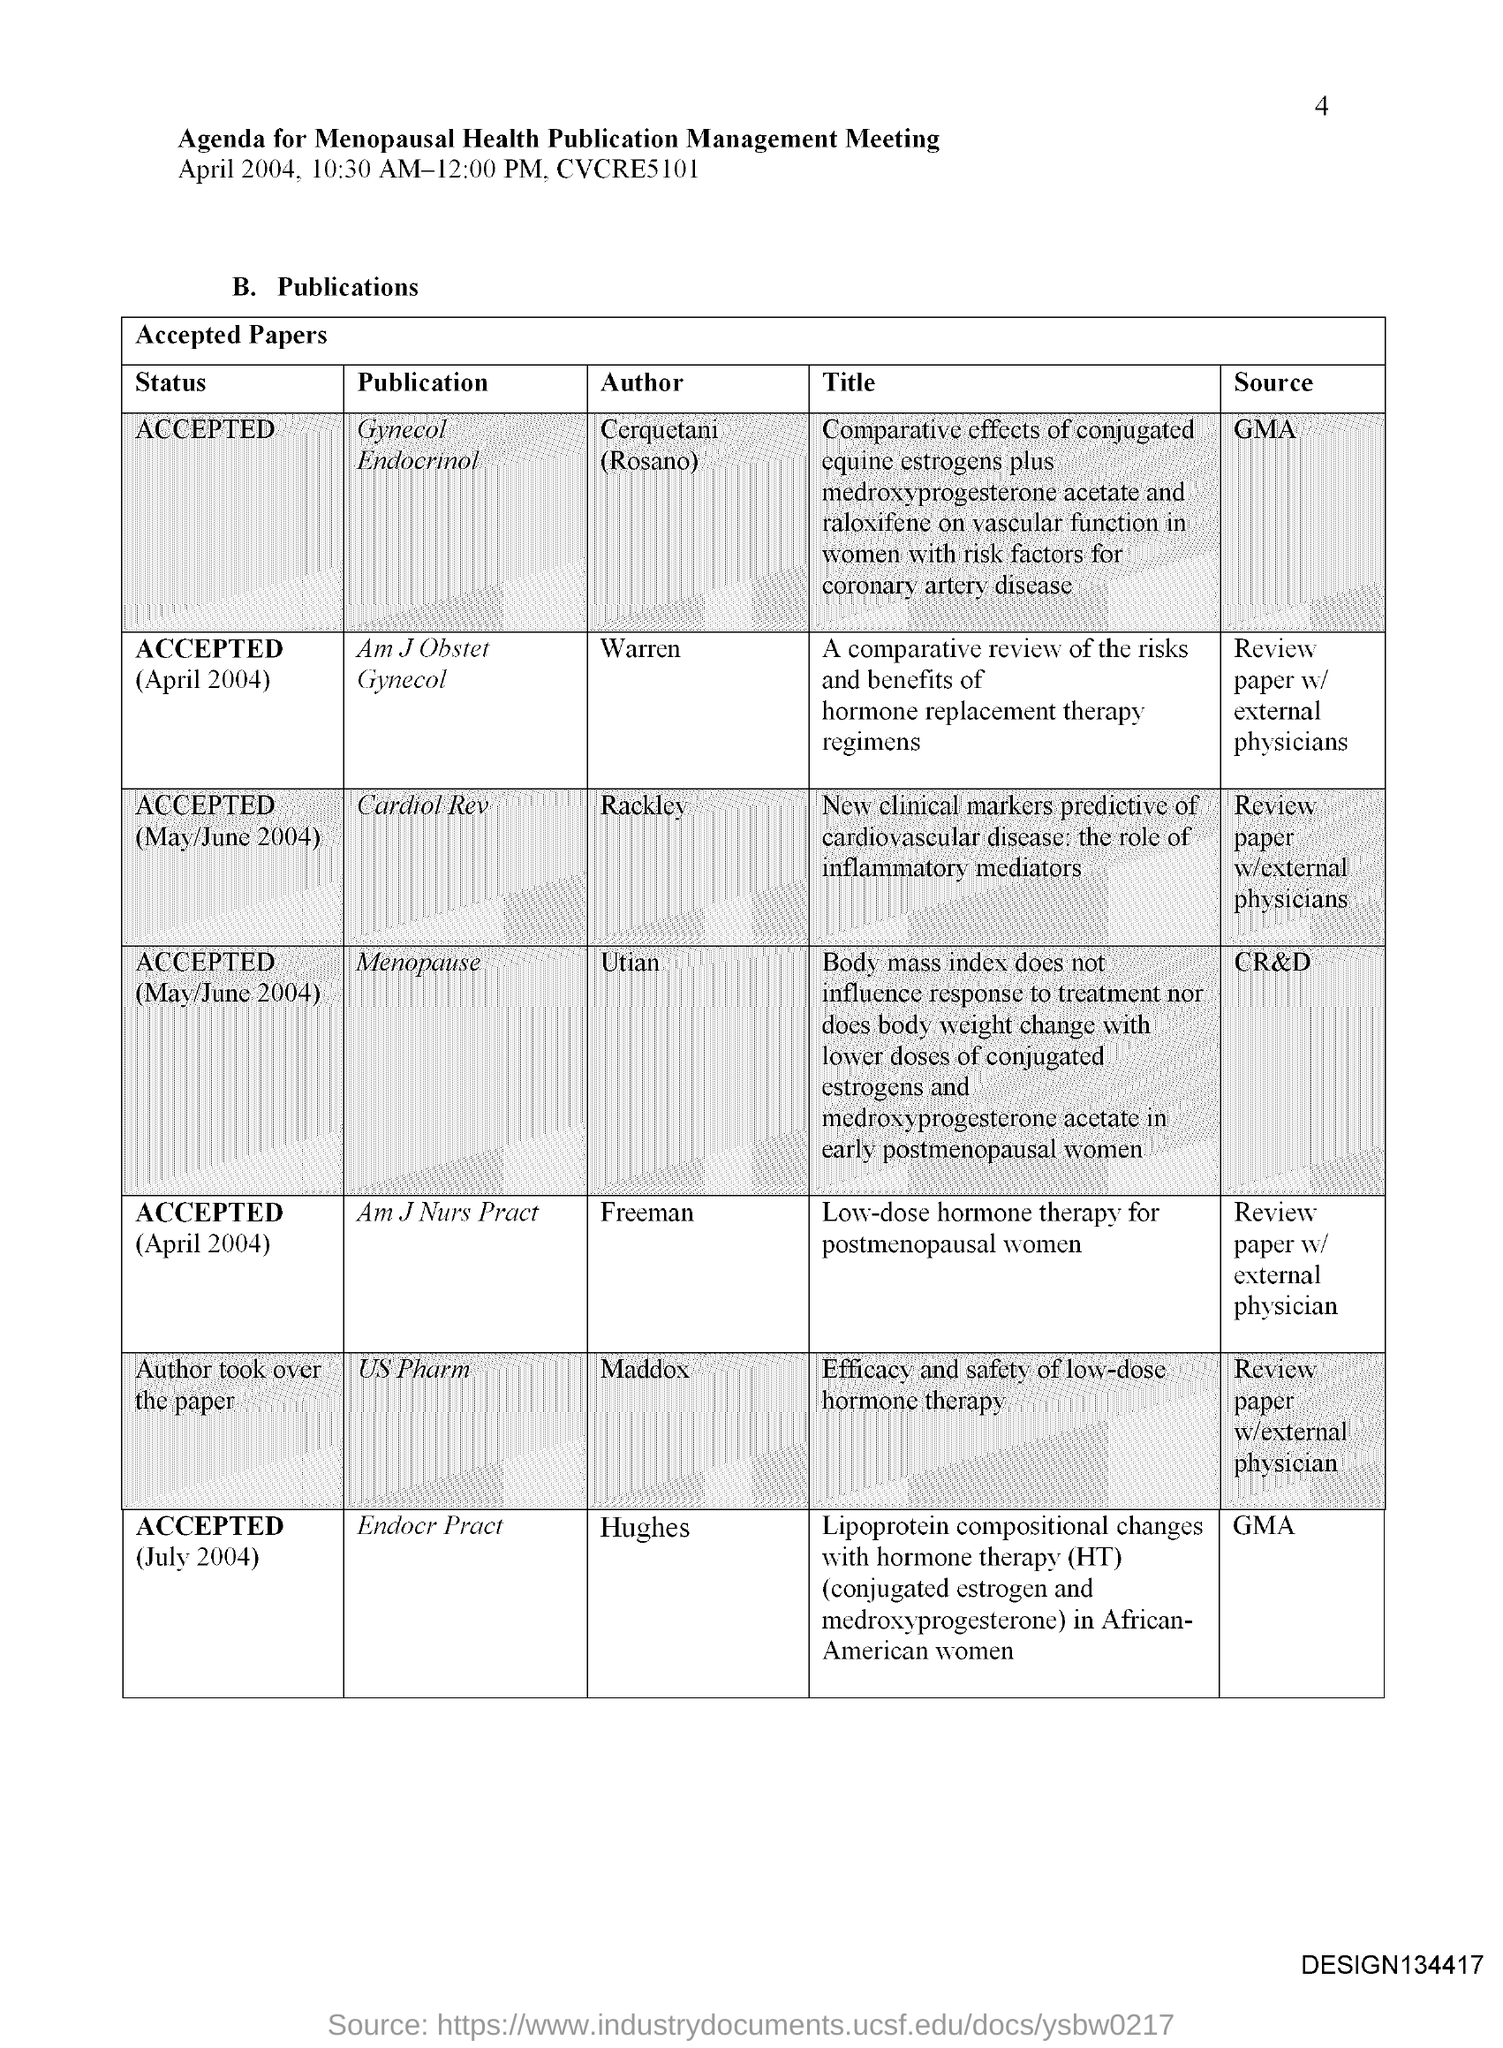Give some essential details in this illustration. The publication in question is "Endocr Pract." by Hughes. Rackley is the author of the publication Cardiol Rev. Utian is the author of the publication "Menopause. 